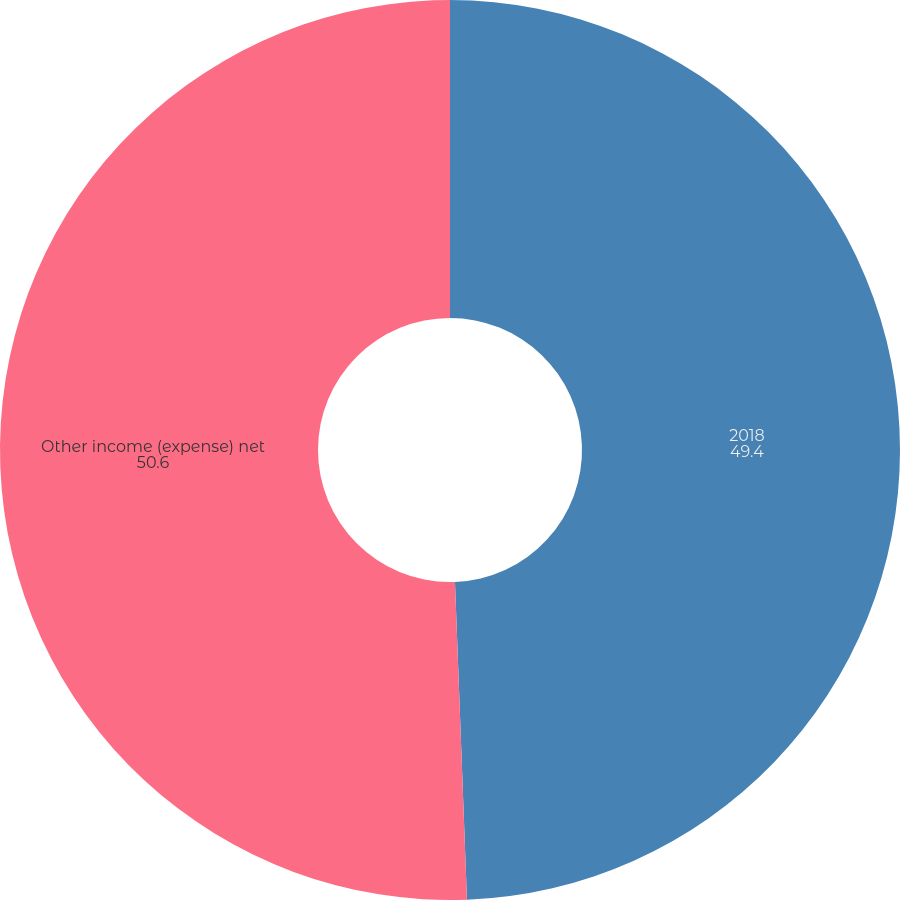Convert chart to OTSL. <chart><loc_0><loc_0><loc_500><loc_500><pie_chart><fcel>2018<fcel>Other income (expense) net<nl><fcel>49.4%<fcel>50.6%<nl></chart> 